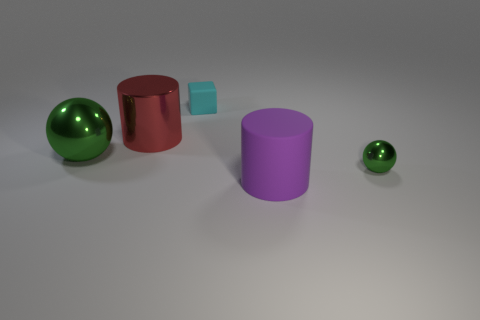Add 4 tiny cubes. How many objects exist? 9 Subtract all spheres. How many objects are left? 3 Add 4 big red shiny cylinders. How many big red shiny cylinders exist? 5 Subtract 0 yellow balls. How many objects are left? 5 Subtract all large red metallic cylinders. Subtract all tiny objects. How many objects are left? 2 Add 5 small balls. How many small balls are left? 6 